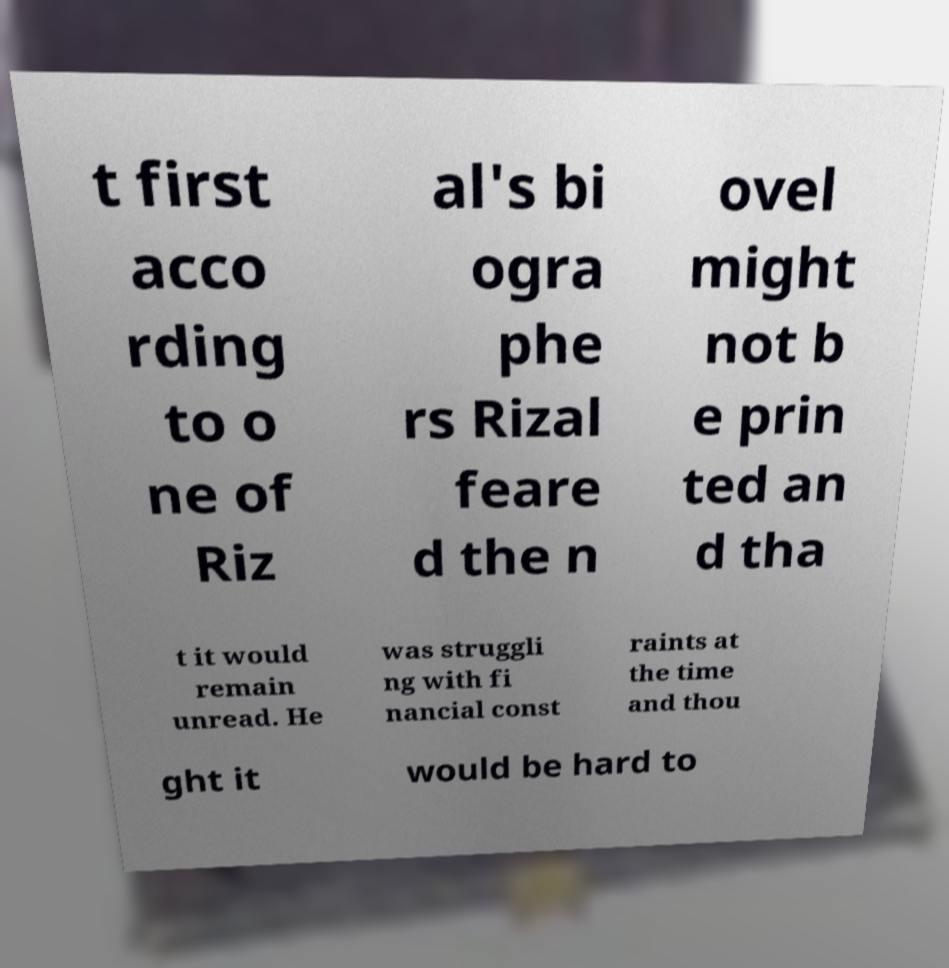Can you accurately transcribe the text from the provided image for me? t first acco rding to o ne of Riz al's bi ogra phe rs Rizal feare d the n ovel might not b e prin ted an d tha t it would remain unread. He was struggli ng with fi nancial const raints at the time and thou ght it would be hard to 